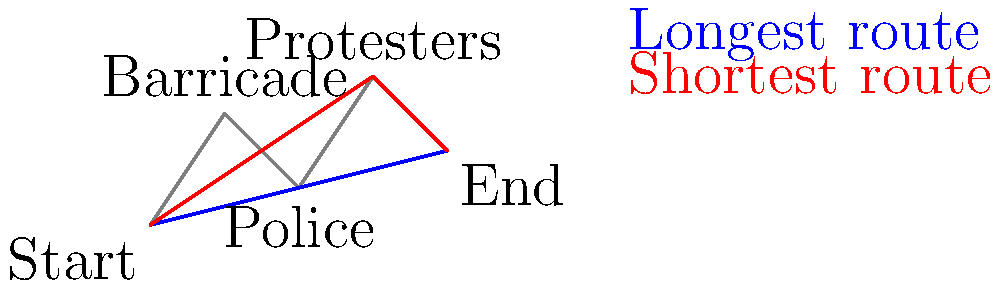As a gonzo journalist embedded in a chaotic protest scene, you need to navigate from the starting point to your getaway vehicle at the end point. Given the map showing various obstacles and two potential routes, which path should you take to minimize your exposure and get the most authentic experience of the event? To answer this question, we need to consider both the efficiency of the route and the gonzo journalism approach:

1. Route analysis:
   - Blue route: Start → Barricade → Police → End
   - Red route: Start → Protesters → End

2. Distance comparison:
   - The red route appears shorter, covering less ground.

3. Gonzo journalism perspective:
   - Joe Bageant, a gonzo journalist, would prioritize immersive experiences and raw, unfiltered observations.
   - The red route takes you directly through the protesters, offering a more authentic and intense experience.

4. Safety considerations:
   - The blue route involves navigating past a barricade and police, which might lead to confrontations or delays.
   - The red route, while potentially more chaotic, aligns better with the gonzo approach of being in the thick of the action.

5. Storytelling potential:
   - The red route provides more opportunities for direct interactions with protesters, yielding richer material for your gonzo-style report.

Conclusion: The red route, while not necessarily the safest, offers the most efficient path combined with the best opportunity for an immersive, gonzo-style reporting experience.
Answer: Red route (through protesters) 